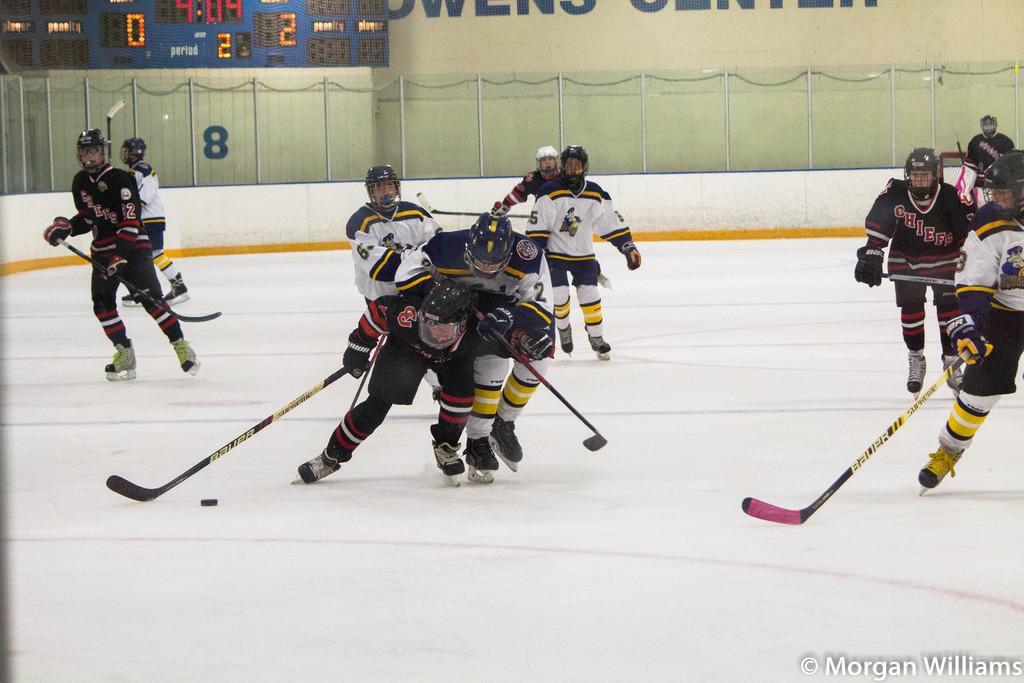Could you give a brief overview of what you see in this image? In the picture we can see these people wearing jackets and skate shoes are holding rackets in their hands and skating on the white color surface. In the background, we can see the LED display board, fence and the wall on which we can see some text. Here we can see the watermark at the bottom right side of the image. 